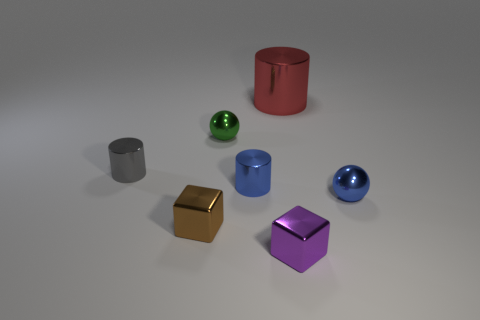Add 2 tiny cubes. How many objects exist? 9 Subtract all spheres. How many objects are left? 5 Add 5 tiny green balls. How many tiny green balls are left? 6 Add 6 blue shiny cylinders. How many blue shiny cylinders exist? 7 Subtract 0 brown spheres. How many objects are left? 7 Subtract all small things. Subtract all cyan metal things. How many objects are left? 1 